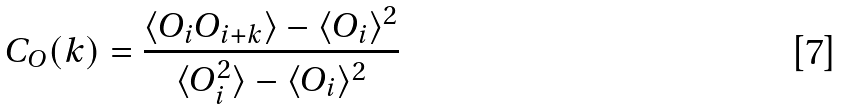Convert formula to latex. <formula><loc_0><loc_0><loc_500><loc_500>C _ { O } ( k ) = \frac { \langle O _ { i } O _ { i + k } \rangle - \langle O _ { i } \rangle ^ { 2 } } { \langle O _ { i } ^ { 2 } \rangle - \langle O _ { i } \rangle ^ { 2 } }</formula> 